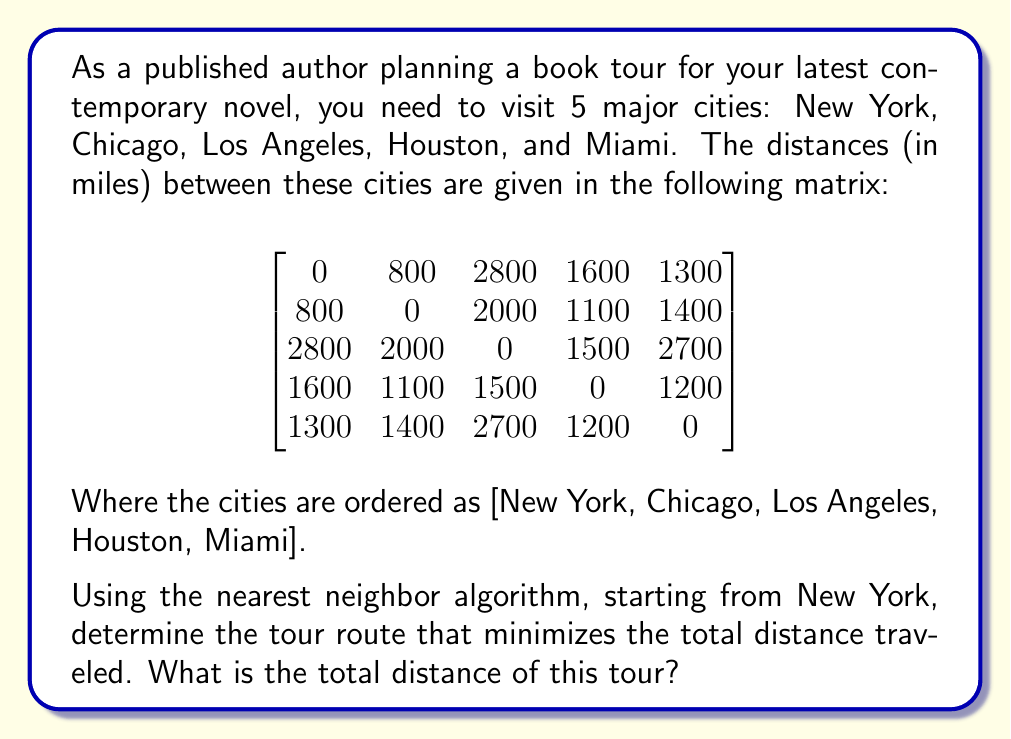Can you solve this math problem? To solve this problem using the nearest neighbor algorithm, we'll follow these steps:

1. Start in New York (the first city).
2. Find the nearest unvisited city and move to it.
3. Repeat step 2 until all cities have been visited.
4. Return to New York to complete the tour.

Let's go through the process:

1. Start in New York.

2. From New York, the distances to unvisited cities are:
   Chicago: 800 miles
   Los Angeles: 2800 miles
   Houston: 1600 miles
   Miami: 1300 miles
   
   The nearest city is Chicago (800 miles). Move to Chicago.

3. From Chicago, the distances to unvisited cities are:
   Los Angeles: 2000 miles
   Houston: 1100 miles
   Miami: 1400 miles
   
   The nearest city is Houston (1100 miles). Move to Houston.

4. From Houston, the distances to unvisited cities are:
   Los Angeles: 1500 miles
   Miami: 1200 miles
   
   The nearest city is Miami (1200 miles). Move to Miami.

5. The only unvisited city left is Los Angeles. Move to Los Angeles (2700 miles).

6. Return to New York to complete the tour (2800 miles).

The tour route is: New York → Chicago → Houston → Miami → Los Angeles → New York

To calculate the total distance:
New York to Chicago: 800 miles
Chicago to Houston: 1100 miles
Houston to Miami: 1200 miles
Miami to Los Angeles: 2700 miles
Los Angeles to New York: 2800 miles

Total distance = 800 + 1100 + 1200 + 2700 + 2800 = 8600 miles
Answer: The tour route that minimizes the total distance traveled using the nearest neighbor algorithm is:
New York → Chicago → Houston → Miami → Los Angeles → New York

The total distance of this tour is 8600 miles. 